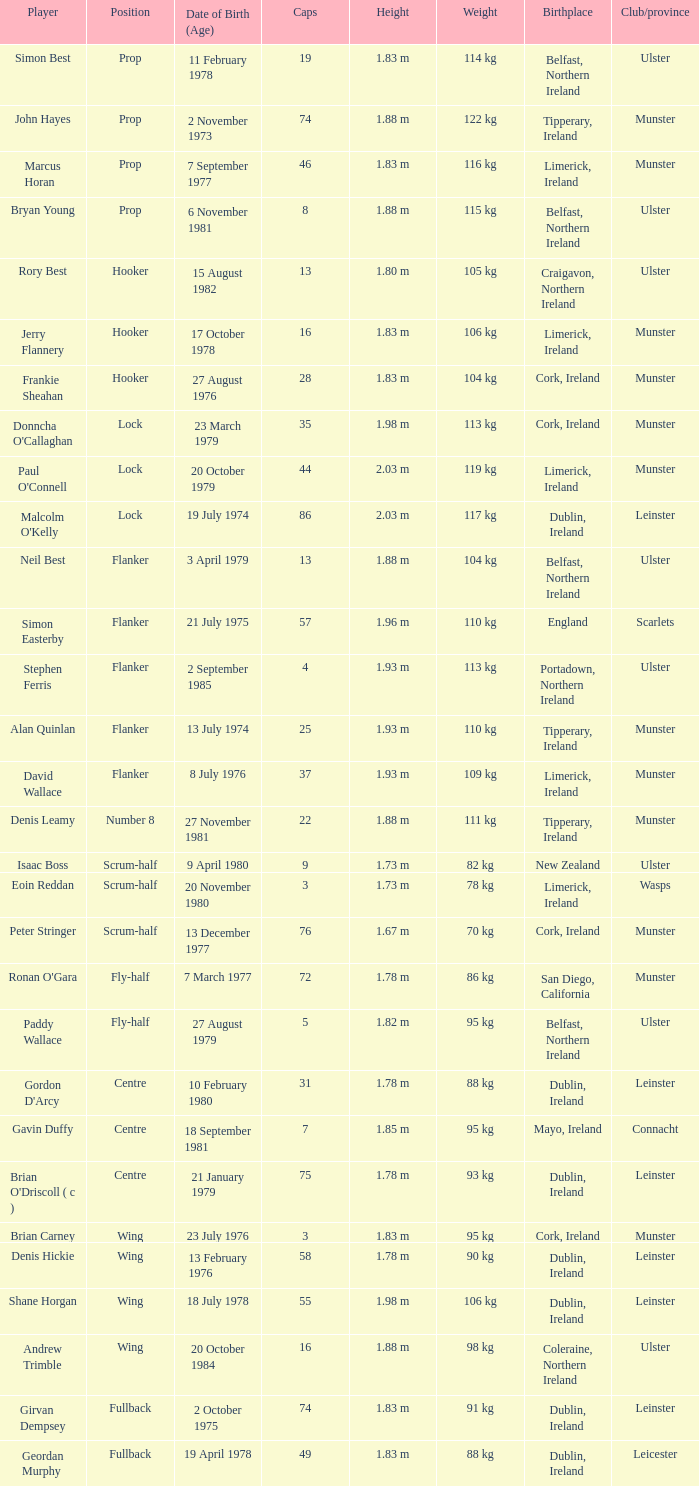Which player Munster from Munster is a fly-half? Ronan O'Gara. 